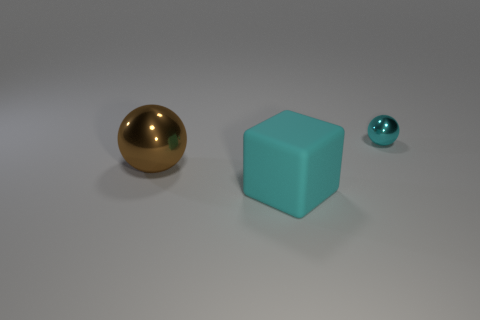There is a metal object that is the same color as the cube; what is its shape?
Your answer should be very brief. Sphere. There is a large matte object; is its color the same as the shiny sphere in front of the tiny cyan metallic sphere?
Make the answer very short. No. Are there more big things left of the big cyan object than brown balls?
Provide a succinct answer. No. How many objects are balls on the right side of the rubber thing or shiny spheres that are right of the big cyan cube?
Keep it short and to the point. 1. There is a brown ball that is made of the same material as the tiny cyan thing; what size is it?
Offer a very short reply. Large. There is a shiny thing behind the big brown sphere; does it have the same shape as the brown object?
Keep it short and to the point. Yes. The metal thing that is the same color as the big rubber object is what size?
Make the answer very short. Small. How many gray objects are either large things or big matte things?
Offer a very short reply. 0. How many other things are the same shape as the big cyan matte thing?
Your response must be concise. 0. The object that is both behind the big cyan matte object and in front of the cyan shiny object has what shape?
Provide a short and direct response. Sphere. 